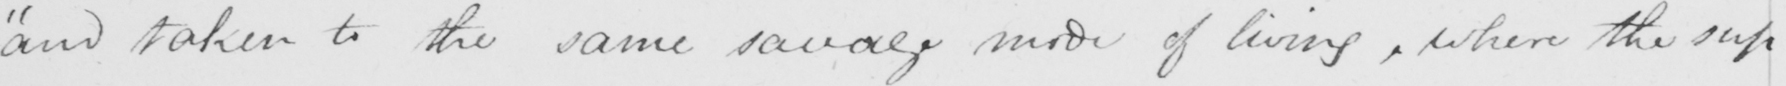What is written in this line of handwriting? "and taken to the same savage mode of living, where the sup- 